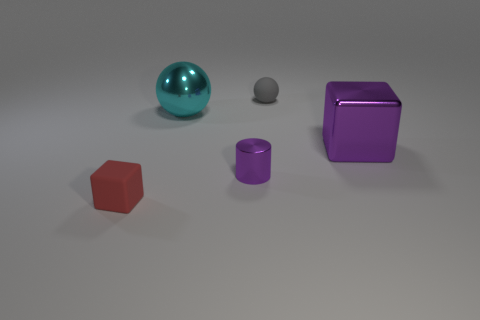There is a small purple object in front of the block that is right of the small red object; what is its material? metal 